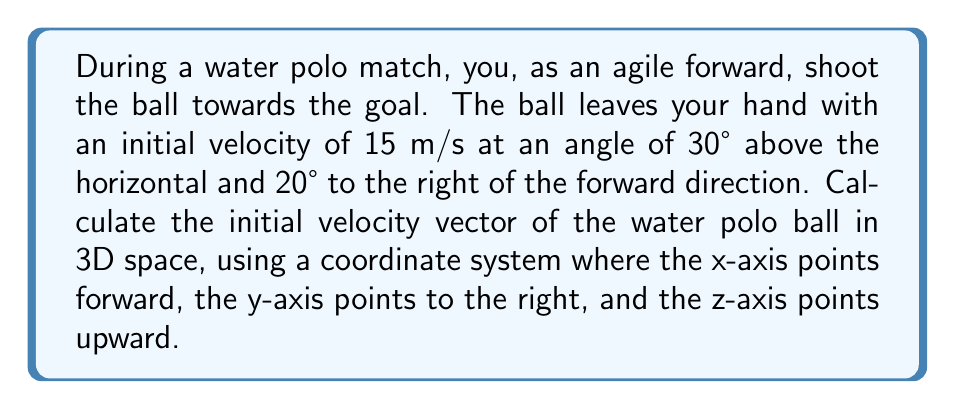Teach me how to tackle this problem. To solve this problem, we need to break down the initial velocity into its components along the x, y, and z axes. We'll use spherical coordinates to do this.

1. First, let's identify our given information:
   - Initial speed: $v = 15$ m/s
   - Angle above horizontal: $\theta = 30°$
   - Angle to the right of forward direction: $\phi = 20°$

2. In spherical coordinates, we can express the velocity components as:
   $$v_x = v \cos\theta \cos\phi$$
   $$v_y = v \cos\theta \sin\phi$$
   $$v_z = v \sin\theta$$

3. Let's calculate each component:

   For $v_x$:
   $$v_x = 15 \cdot \cos(30°) \cdot \cos(20°) = 15 \cdot (\frac{\sqrt{3}}{2}) \cdot (0.9397) = 12.22 \text{ m/s}$$

   For $v_y$:
   $$v_y = 15 \cdot \cos(30°) \cdot \sin(20°) = 15 \cdot (\frac{\sqrt{3}}{2}) \cdot (0.3420) = 4.44 \text{ m/s}$$

   For $v_z$:
   $$v_z = 15 \cdot \sin(30°) = 15 \cdot (0.5) = 7.5 \text{ m/s}$$

4. Now we can express the velocity vector in 3D space:
   $$\vec{v} = (12.22, 4.44, 7.5) \text{ m/s}$$

This vector represents the initial velocity of the water polo ball in the given coordinate system.
Answer: The initial velocity vector of the water polo ball is $\vec{v} = (12.22, 4.44, 7.5) \text{ m/s}$. 